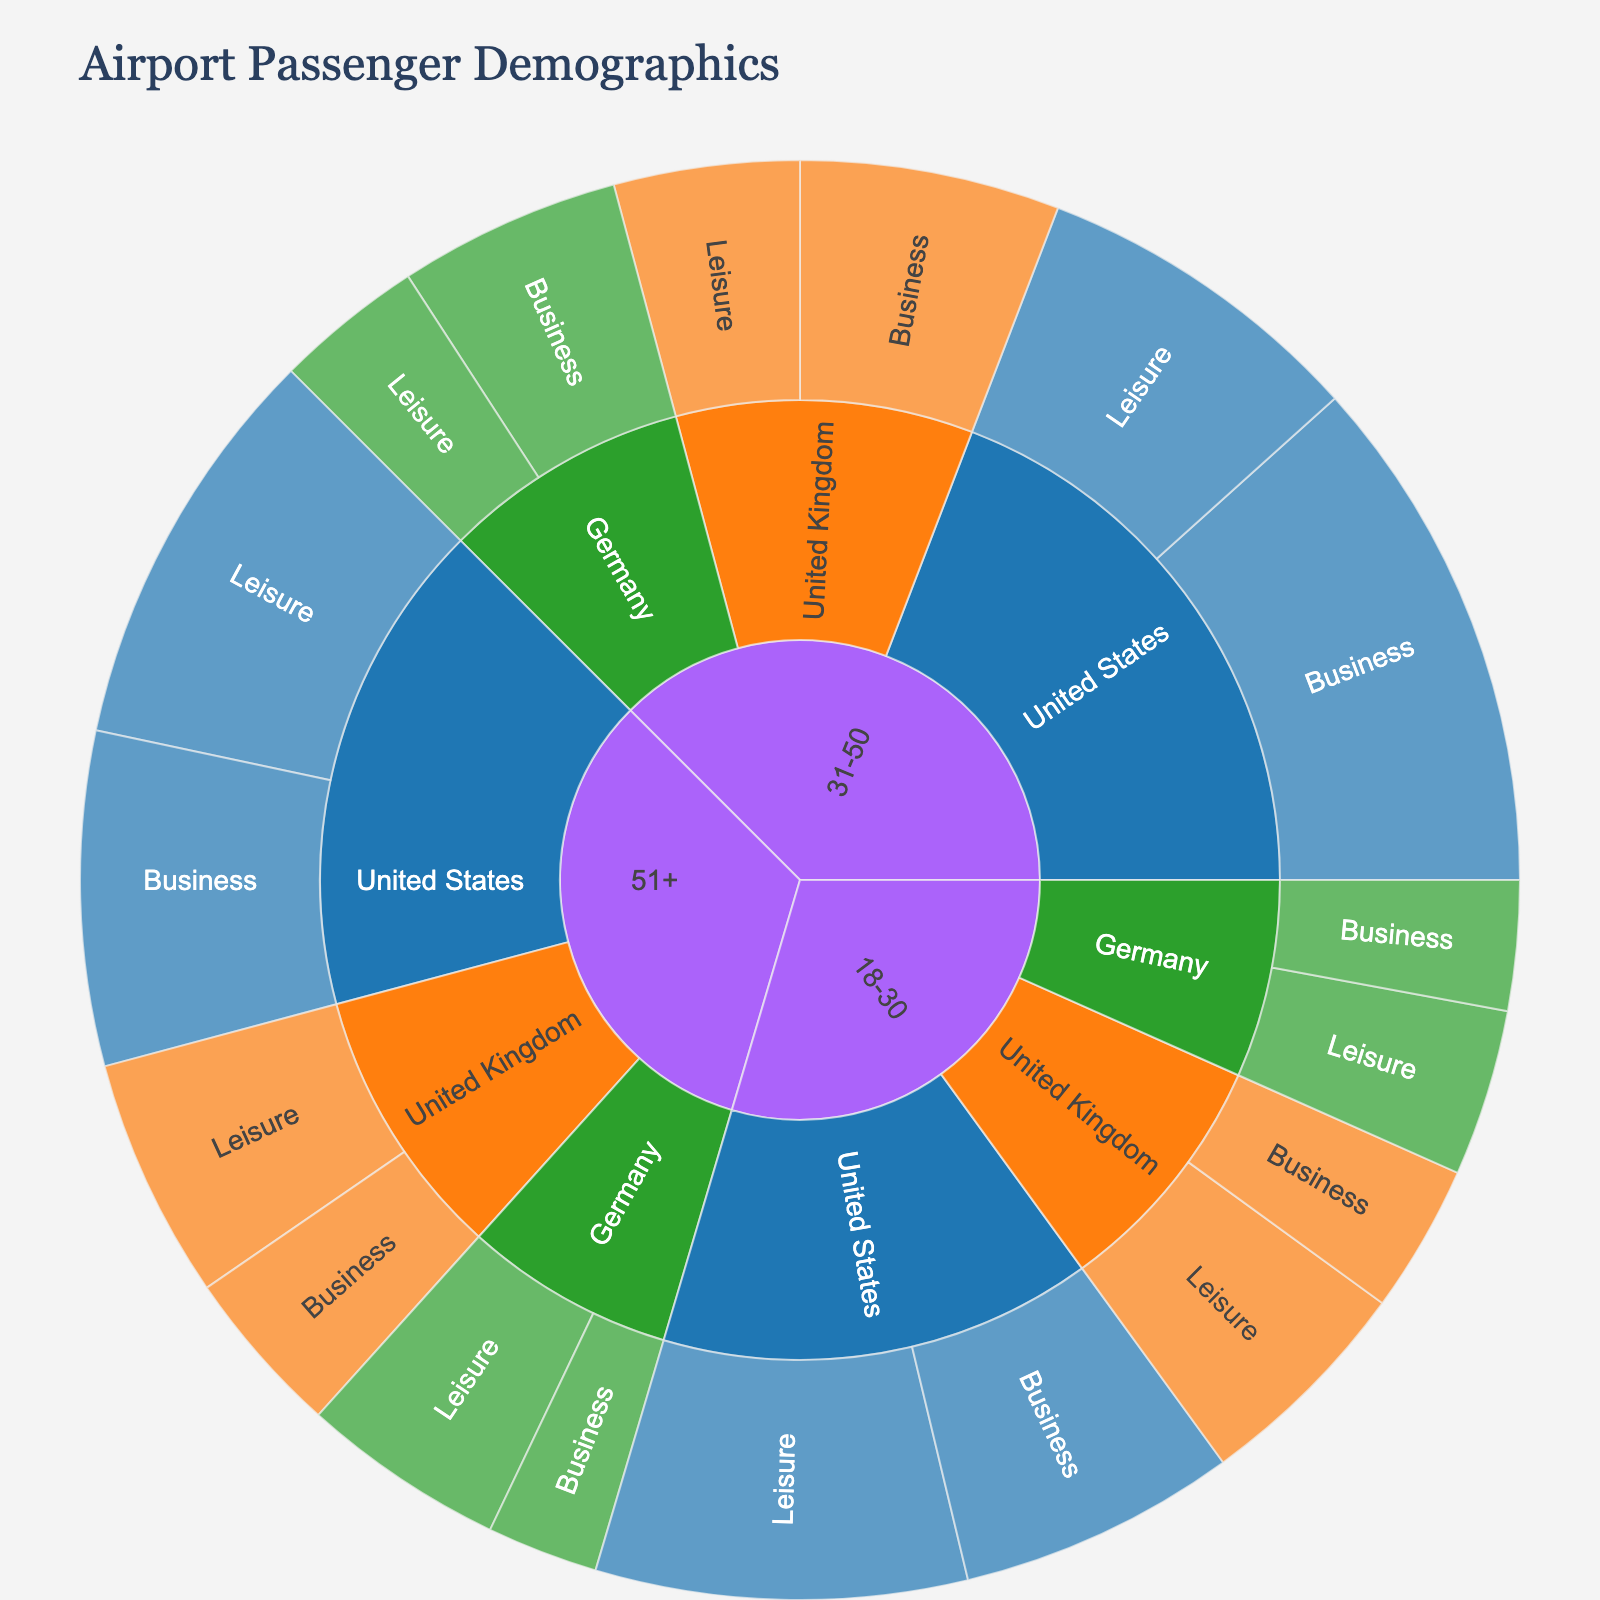What's the title of the figure? The title is usually prominently displayed at the top of the plot for easy identification. Look at the text in bold, large font near the top.
Answer: Airport Passenger Demographics Which nationality has the highest number of business travelers in the 31-50 age group? Identify the 31-50 age group segment, then within that group, look at the business travelers. Compare the values for United States, United Kingdom, and Germany.
Answer: United States What is the total number of passengers who travel for leisure from all nationalities combined? Sum the values under the leisure travel purpose for all nationalities and age groups. For 18-30: 200 + 120 + 90 = 410; for 31-50: 180 + 100 + 80 = 360; for 51+: 220 + 130 + 110 = 460. Then add these sums together: 410 + 360 + 460.
Answer: 1230 How do business and leisure travel values compare for German passengers in the 51+ age group? Locate the 51+ age group and find the segments for Germany. Compare the values listed for business (60) and leisure (110) travel purposes.
Answer: Leisure is higher by 50 What age group has the highest number of passengers from the United Kingdom traveling for business purposes? Identify and compare the values for business travelers from the United Kingdom across the different age groups: 18-30 (80), 31-50 (140), and 51+ (90).
Answer: 31-50 What's the overall proportion of business travelers among all passengers? First, determine the total number of business travelers across all age groups and nationalities, then divide by the total number of passengers (business + leisure) and convert to a percentage. Total business: 150+80+70+280+140+120+180+90+60 = 1170. Total: 1500 (calculated by summing all values as shown in the explanation for total passengers). Proportion is 1170/2670 * 100%.
Answer: ~43.82% Which age group in the United States has the least number of leisure travelers? Compare the values for leisure travel in the United States across the age groups: 18-30 (200), 31-50 (180), and 51+ (220).
Answer: 31-50 How many business travelers aged 18-30 are there overall? Add the values from the business travel purpose for all nationalities within the 18-30 age group: 150 (US) + 80 (UK) + 70 (Germany).
Answer: 300 What is the ratio of leisure travelers to business travelers in the 51+ age group? Calculate the total number of leisure travelers and business travelers in the 51+ age group, then simplify the ratio. Business 51+: 180+90+60 = 330; Leisure 51+: 220+130+110 = 460; Ratio: 460/330, simplified.
Answer: 46:33 